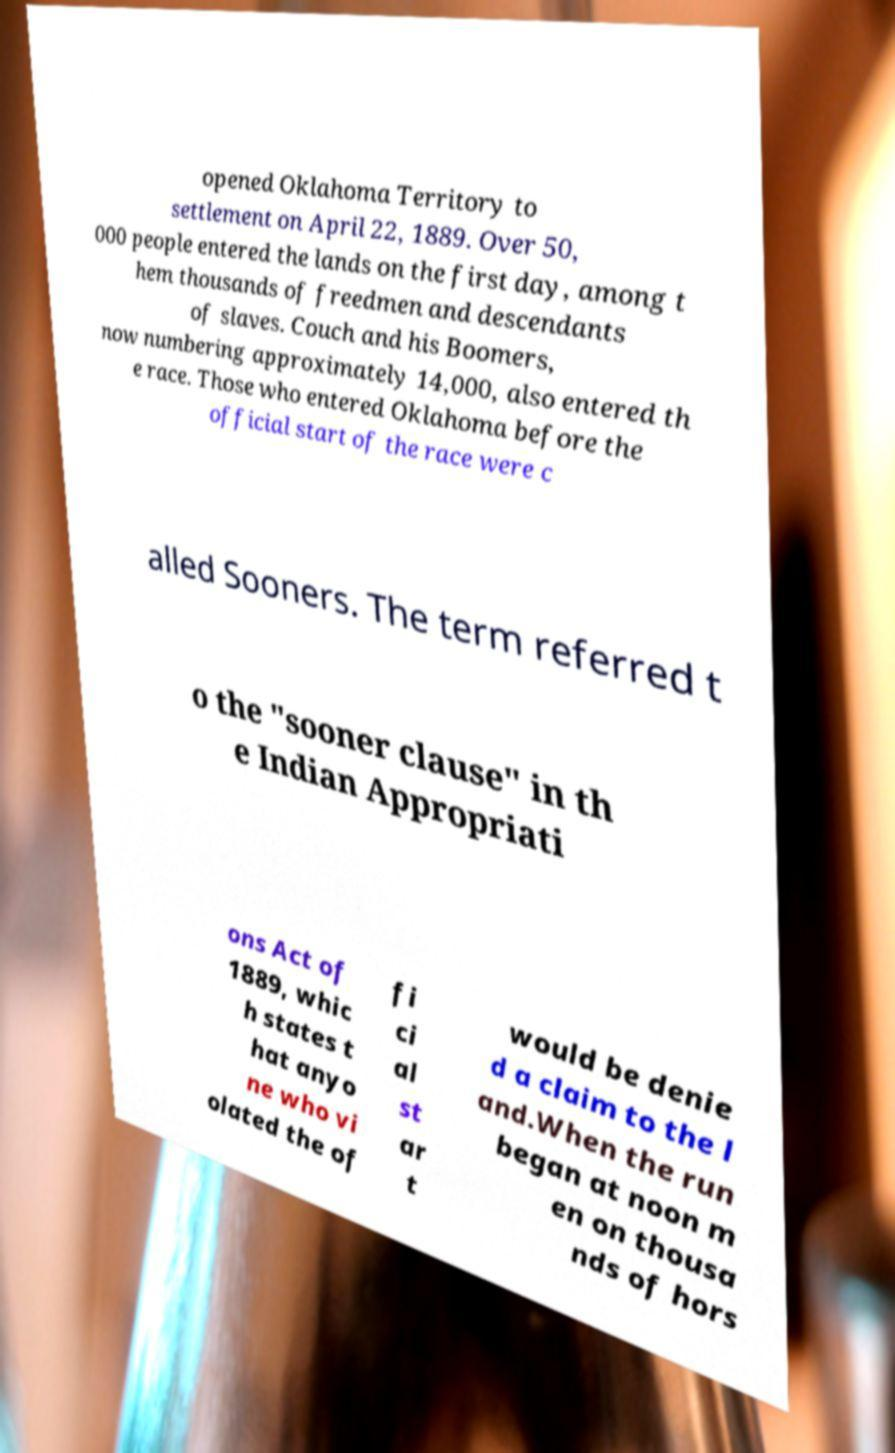Can you read and provide the text displayed in the image?This photo seems to have some interesting text. Can you extract and type it out for me? opened Oklahoma Territory to settlement on April 22, 1889. Over 50, 000 people entered the lands on the first day, among t hem thousands of freedmen and descendants of slaves. Couch and his Boomers, now numbering approximately 14,000, also entered th e race. Those who entered Oklahoma before the official start of the race were c alled Sooners. The term referred t o the "sooner clause" in th e Indian Appropriati ons Act of 1889, whic h states t hat anyo ne who vi olated the of fi ci al st ar t would be denie d a claim to the l and.When the run began at noon m en on thousa nds of hors 